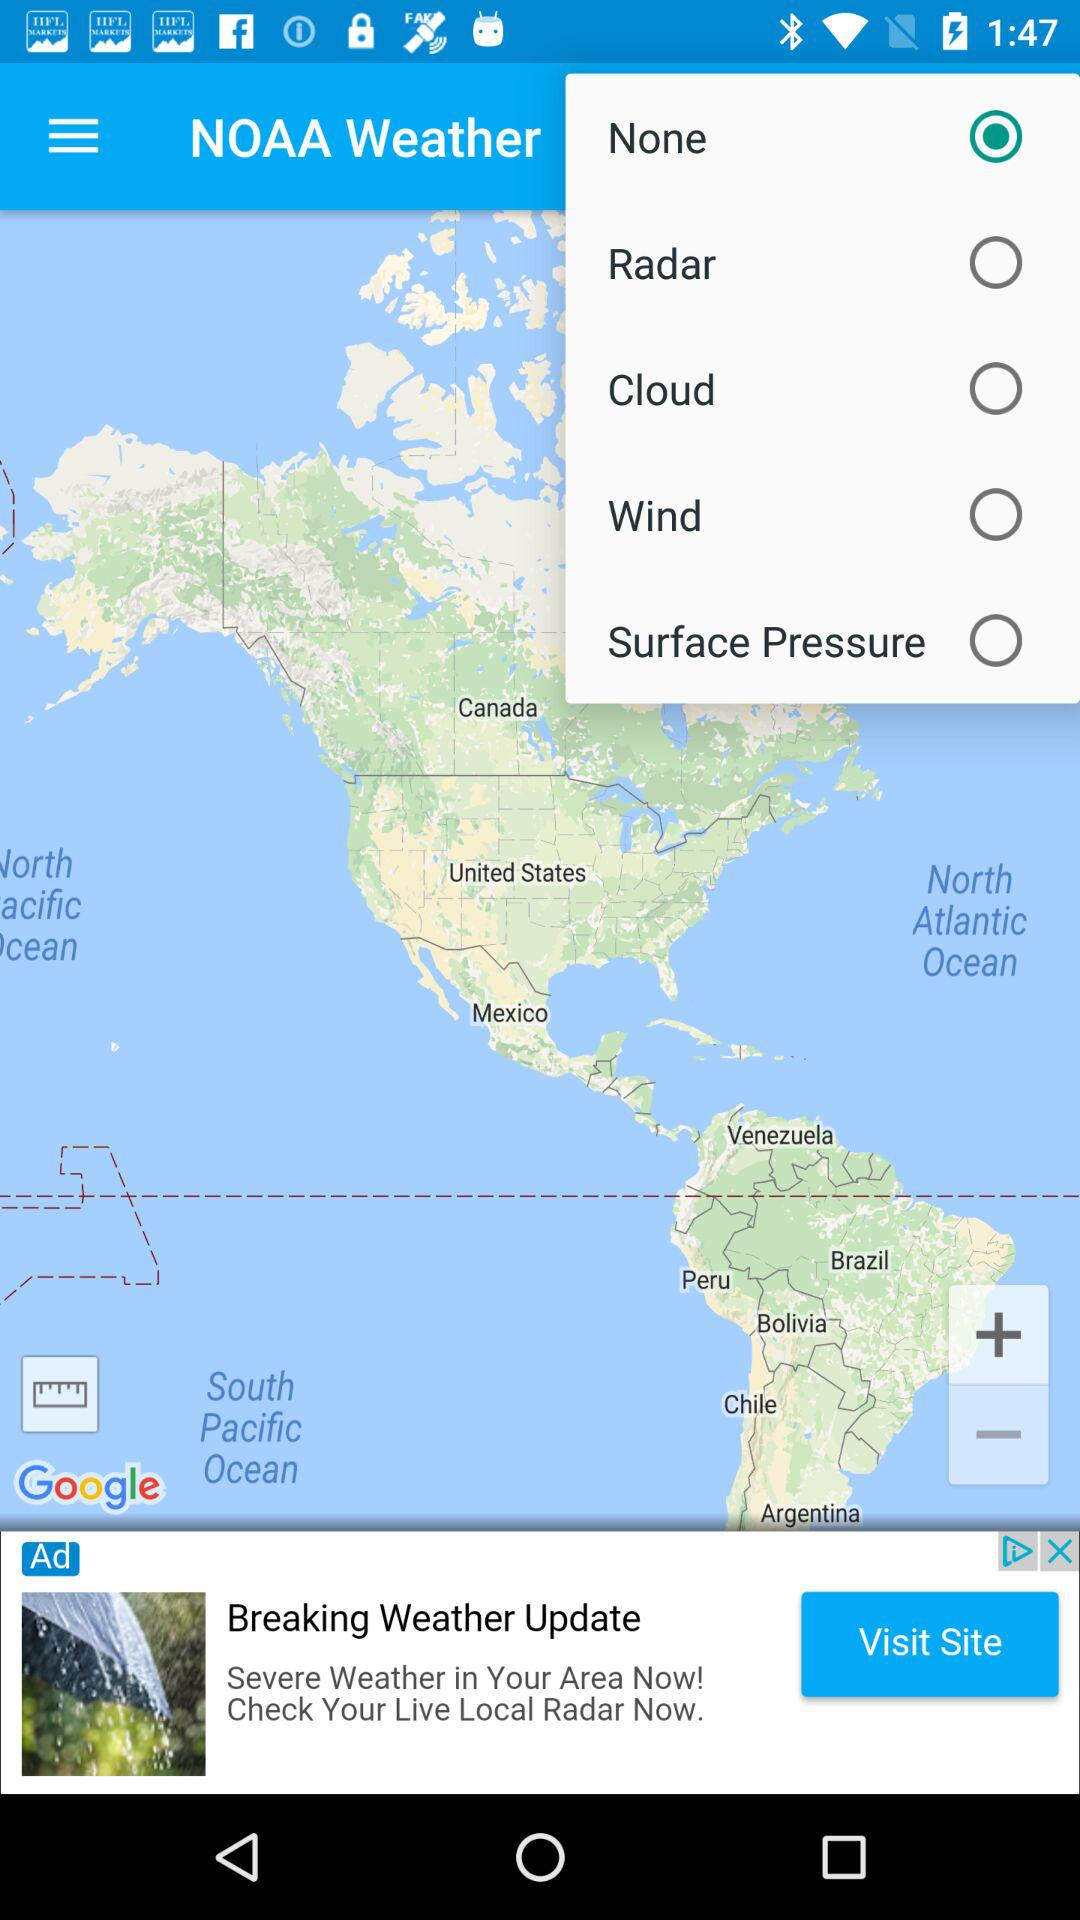What is the selected option? The selected option is "None". 